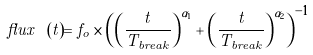Convert formula to latex. <formula><loc_0><loc_0><loc_500><loc_500>f l u x \ ( t ) = f _ { o } \times \left ( \left ( \frac { t } { T _ { b r e a k } } \right ) ^ { \alpha _ { 1 } } + \left ( \frac { t } { T _ { b r e a k } } \right ) ^ { \alpha _ { 2 } } \right ) ^ { - 1 }</formula> 